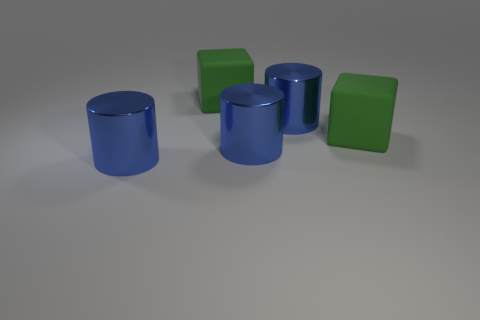Are any blue rubber cylinders visible?
Provide a succinct answer. No. How many metal things are large blue cylinders or green things?
Offer a very short reply. 3. How many blue things are blocks or large cylinders?
Your answer should be compact. 3. Are there more blue metal cylinders than green blocks?
Keep it short and to the point. Yes. What number of cylinders are big blue metallic things or large matte things?
Provide a succinct answer. 3. Are there fewer blue shiny objects than rubber cubes?
Offer a terse response. No. How many things are cylinders or matte cubes?
Provide a short and direct response. 5. How many blocks are there?
Your answer should be compact. 2. What number of tiny objects are either metallic things or green cubes?
Your response must be concise. 0. 